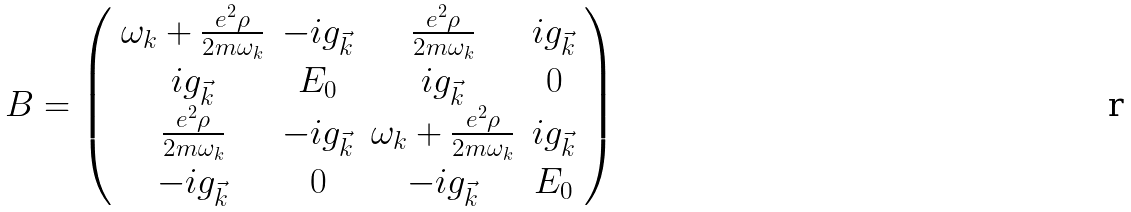Convert formula to latex. <formula><loc_0><loc_0><loc_500><loc_500>B = \left ( \begin{array} { c c c c } \omega _ { k } + \frac { e ^ { 2 } \rho } { 2 m \omega _ { k } } & - i g _ { \vec { k } } & \frac { e ^ { 2 } \rho } { 2 m \omega _ { k } } & i g _ { \vec { k } } \\ i g _ { \vec { k } } & E _ { 0 } & i g _ { \vec { k } } & 0 \\ \frac { e ^ { 2 } \rho } { 2 m \omega _ { k } } & - i g _ { \vec { k } } & \omega _ { k } + \frac { e ^ { 2 } \rho } { 2 m \omega _ { k } } & i g _ { \vec { k } } \\ - i g _ { \vec { k } } & 0 & - i g _ { \vec { k } } & E _ { 0 } \end{array} \right )</formula> 